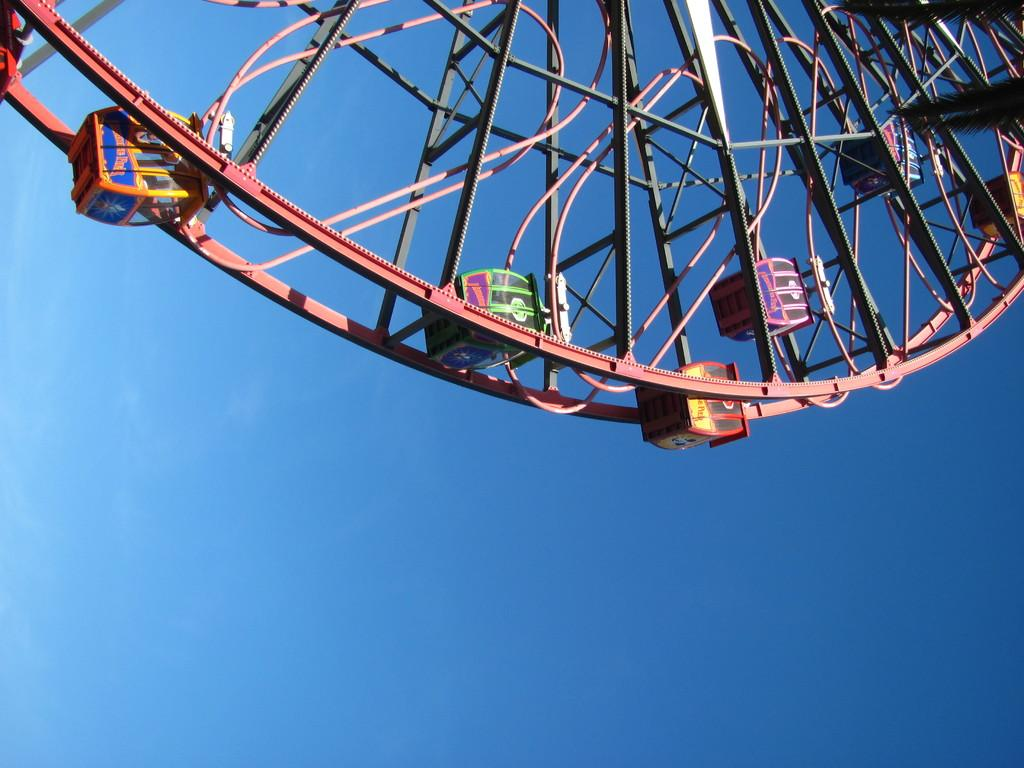What is the main subject of the image? The main subject of the image is a giant-wheel. What colors are present on the giant-wheel? The giant-wheel has red, yellow, blue, green, purple, and black colors. What is the color of the sky in the image? The sky is blue in the image. What type of nerve can be seen stimulating the drum in the image? There is no nerve or drum present in the image; it features a giant-wheel with specific colors and a blue sky. 